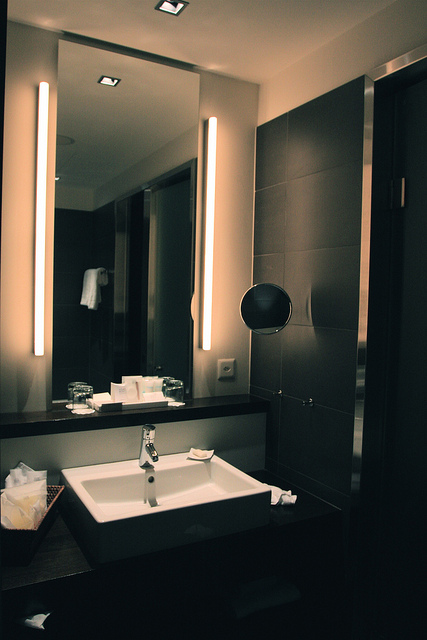Can you identify any decorative elements in the bathroom? The bathroom features minimalistic yet stylish decorative elements including a sleek mirror design with vertical light fixtures on either side, a modern sink with clean lines, and a neatly placed folded towel on the rack in the reflection. The dark tiles add a touch of sophistication and modernity to the space. 